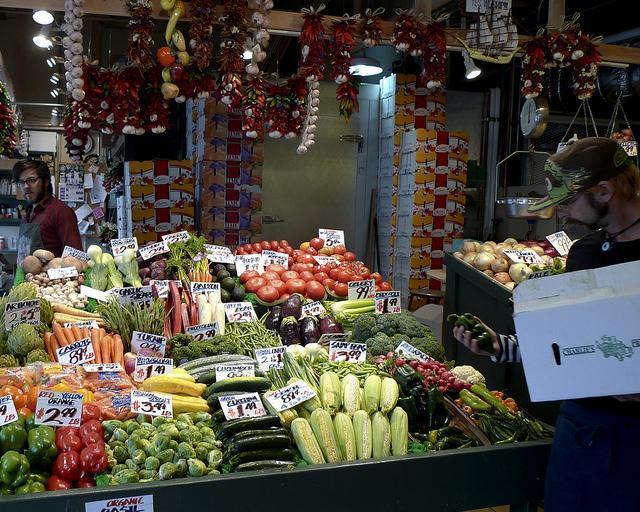Which vegetable is likely the most expensive item by piece or pound?
Choose the right answer from the provided options to respond to the question.
Options: Artichoke, celery, corn, turnips. Artichoke. 